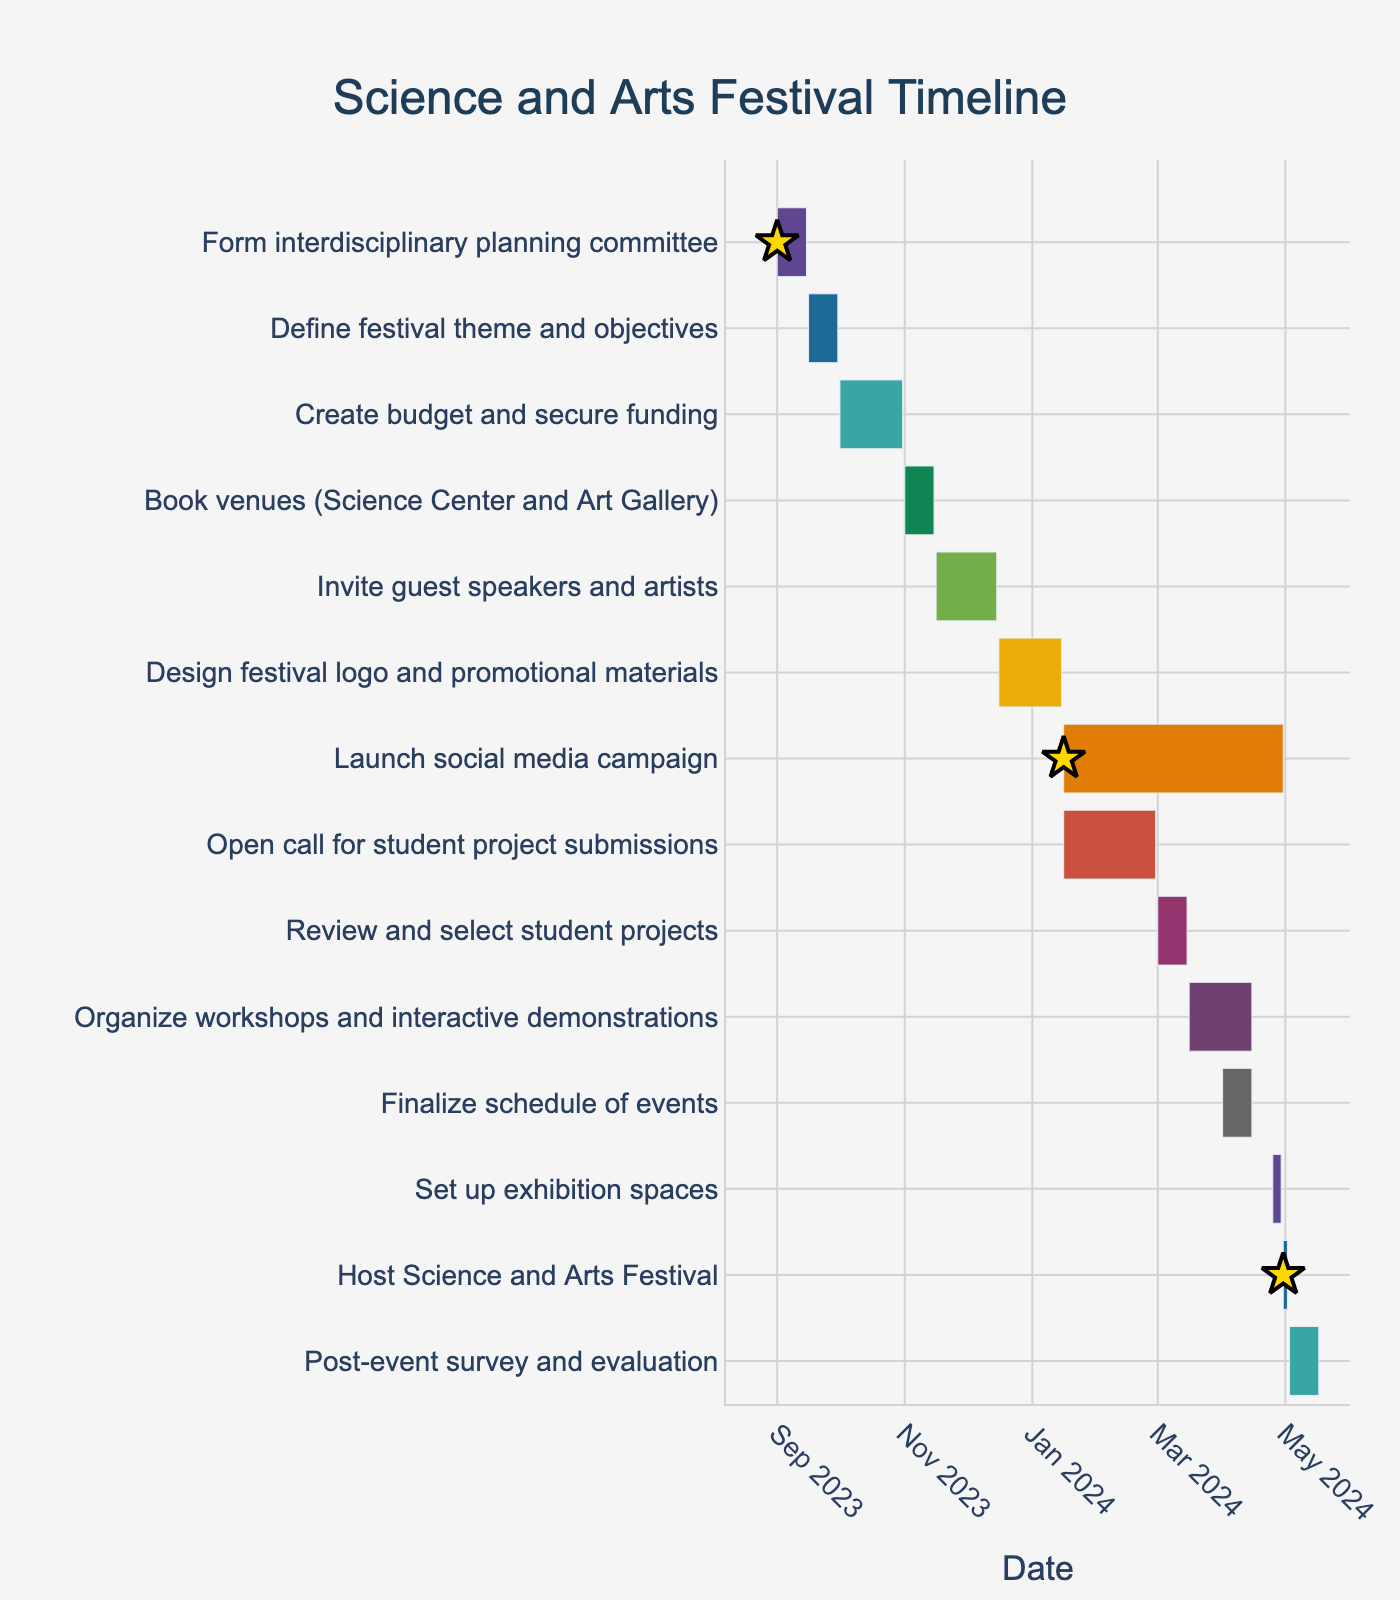What is the title of the Gantt Chart? Look at the top of the figure. The title is usually displayed prominently there.
Answer: Science and Arts Festival Timeline When does the 'Review and select student projects' task begin? The start date for tasks is indicated by the left edge of each rectangular bar. Locate the 'Review and select student projects' task on the y-axis and follow the bar leftward to see where it begins.
Answer: 2024-03-01 Which task has the longest duration? The duration of each task is represented by the length of the corresponding bar. Compare the lengths of bars to see which is the longest.
Answer: 'Launch social media campaign' When is the 'Host Science and Arts Festival' taking place? Locate the 'Host Science and Arts Festival' task on the y-axis and refer to the start and end dates represented by the edges of the bar.
Answer: 2024-04-30 to 2024-05-02 Are there any overlapping tasks in January 2024? Identify bars starting, ending, or spanning January 2024 within the timeline. Check if any of these bars overlap during this period.
Answer: Yes, 'Design festival logo and promotional materials,' 'Launch social media campaign,' and 'Open call for student project submissions' overlap in January 2024 How many days does it take to design the festival logo and promotional materials? The duration of a task can be calculated by subtracting the start date from the end date and adding one day. Look at the 'Design festival logo and promotional materials' task.
Answer: 31 days What tasks are scheduled to end in April 2024? Locate the tasks with bars ending in April 2024 by checking the right edges of bars within the April 2024 period on the x-axis.
Answer: 'Launch social media campaign,' 'Organize workshops and interactive demonstrations,' 'Review and select student projects,' and 'Finalize schedule of events' Which task marks the beginning of the festival execution phase? Look for the first task that directly relates to the festival's execution on the timeline, which should be close to the festival date. Referring to key milestones might help.
Answer: 'Set up exhibition spaces' How long is the post-event survey and evaluation phase? Similar to calculating other task durations, subtract the start date from the end date and add one day for the 'Post-event survey and evaluation' phase.
Answer: 15 days When does the 'Finalize schedule of events' task occur in relation to the 'Organize workshops and interactive demonstrations' task? Identify the time span of both tasks on the y-axis. Check the start and end dates of 'Finalize schedule of events' relative to 'Organize workshops and interactive demonstrations'.
Answer: 'Finalize schedule of events' occurs partially within the same timeframe but ends later 